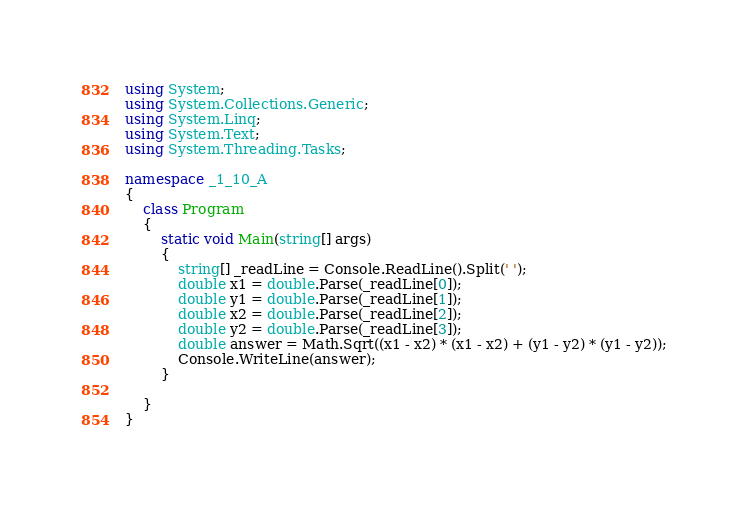<code> <loc_0><loc_0><loc_500><loc_500><_C#_>using System;
using System.Collections.Generic;
using System.Linq;
using System.Text;
using System.Threading.Tasks;

namespace _1_10_A
{
    class Program
    {
        static void Main(string[] args)
        {
            string[] _readLine = Console.ReadLine().Split(' ');
            double x1 = double.Parse(_readLine[0]);
            double y1 = double.Parse(_readLine[1]);
            double x2 = double.Parse(_readLine[2]);
            double y2 = double.Parse(_readLine[3]);
            double answer = Math.Sqrt((x1 - x2) * (x1 - x2) + (y1 - y2) * (y1 - y2));
            Console.WriteLine(answer);
        }

    }
}

</code> 